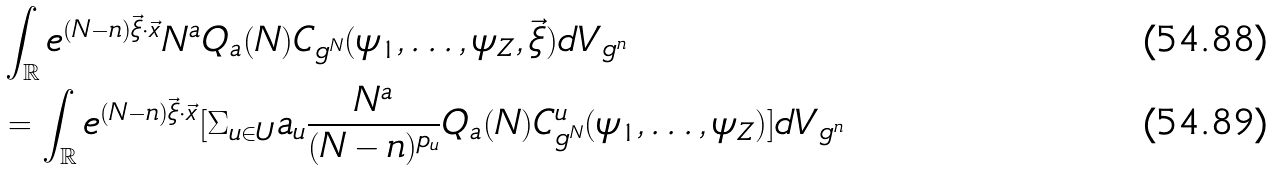<formula> <loc_0><loc_0><loc_500><loc_500>& \int _ { \mathbb { R } } e ^ { ( N - n ) \vec { \xi } \cdot \vec { x } } N ^ { a } Q _ { a } ( N ) C _ { g ^ { N } } ( { \psi } _ { 1 } , \dots , { \psi } _ { Z } , \vec { \xi } ) d V _ { g ^ { n } } \\ & = \int _ { \mathbb { R } } e ^ { ( N - n ) \vec { \xi } \cdot \vec { x } } [ \Sigma _ { u \in U } a _ { u } \frac { N ^ { a } } { ( N - n ) ^ { p _ { u } } } Q _ { a } ( N ) C ^ { u } _ { g ^ { N } } ( { \psi } _ { 1 } , \dots , { \psi } _ { Z } ) ] d V _ { g ^ { n } }</formula> 